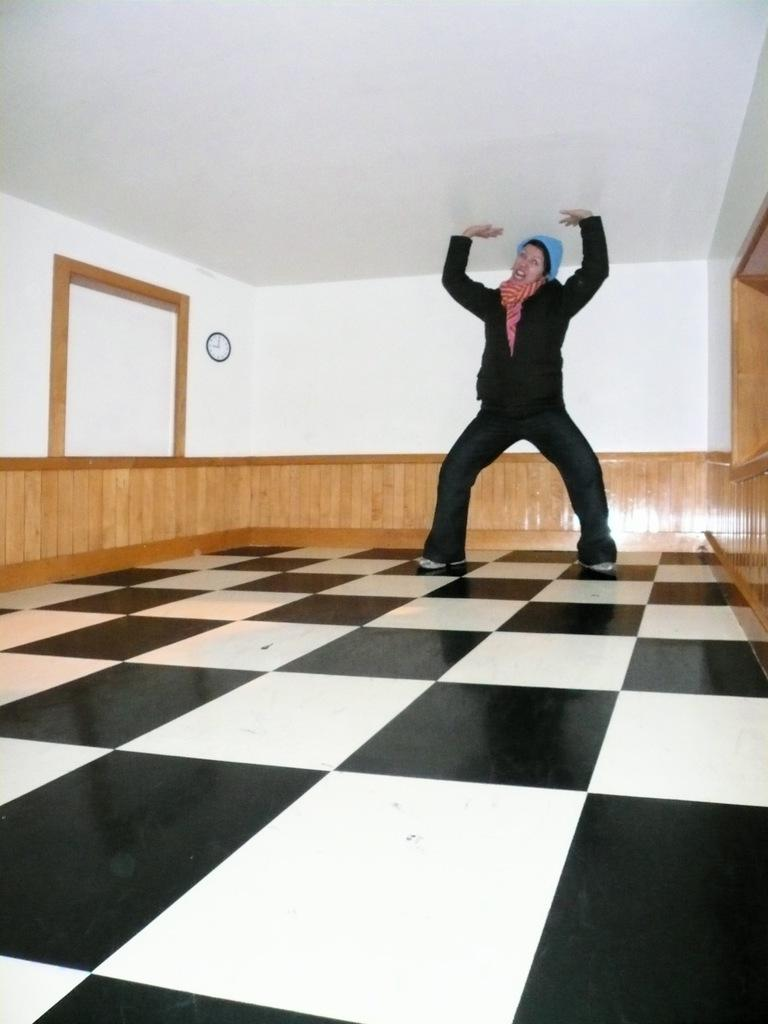What is present in the room according to the image? There is a person in the room. Can you describe the person's attire? The person is wearing a black dress and a cap. What is the color scheme of the room's surface? The surface in the room is black and white in color. What can be seen on the wall in the room? There is a clock on the wall. What is the color of the roof and walls in the room? The roof and walls are white in color. How many holes can be seen in the person's dress in the image? There are no holes visible in the person's dress in the image. What type of quill is the person holding in the image? There is no quill present in the image. 